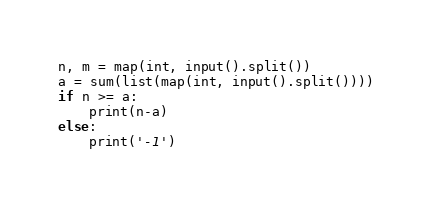Convert code to text. <code><loc_0><loc_0><loc_500><loc_500><_Python_>n, m = map(int, input().split())
a = sum(list(map(int, input().split())))
if n >= a:
    print(n-a)
else:
    print('-1')</code> 